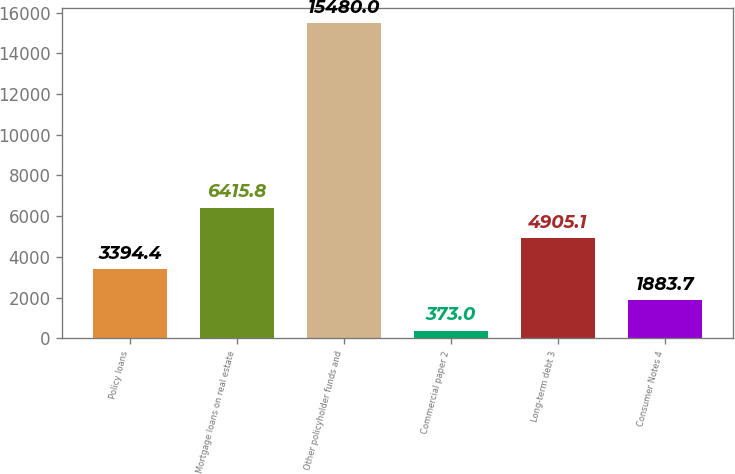Convert chart to OTSL. <chart><loc_0><loc_0><loc_500><loc_500><bar_chart><fcel>Policy loans<fcel>Mortgage loans on real estate<fcel>Other policyholder funds and<fcel>Commercial paper 2<fcel>Long-term debt 3<fcel>Consumer Notes 4<nl><fcel>3394.4<fcel>6415.8<fcel>15480<fcel>373<fcel>4905.1<fcel>1883.7<nl></chart> 